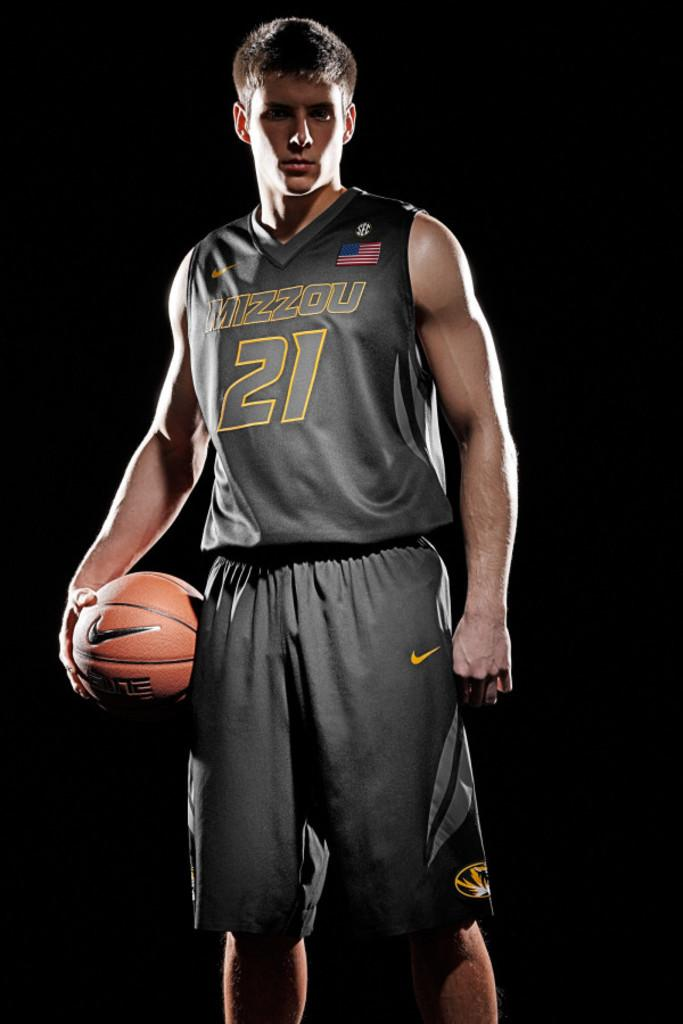<image>
Share a concise interpretation of the image provided. Basketball player in grey uniform printed MIZZOU 21 on jersey. 